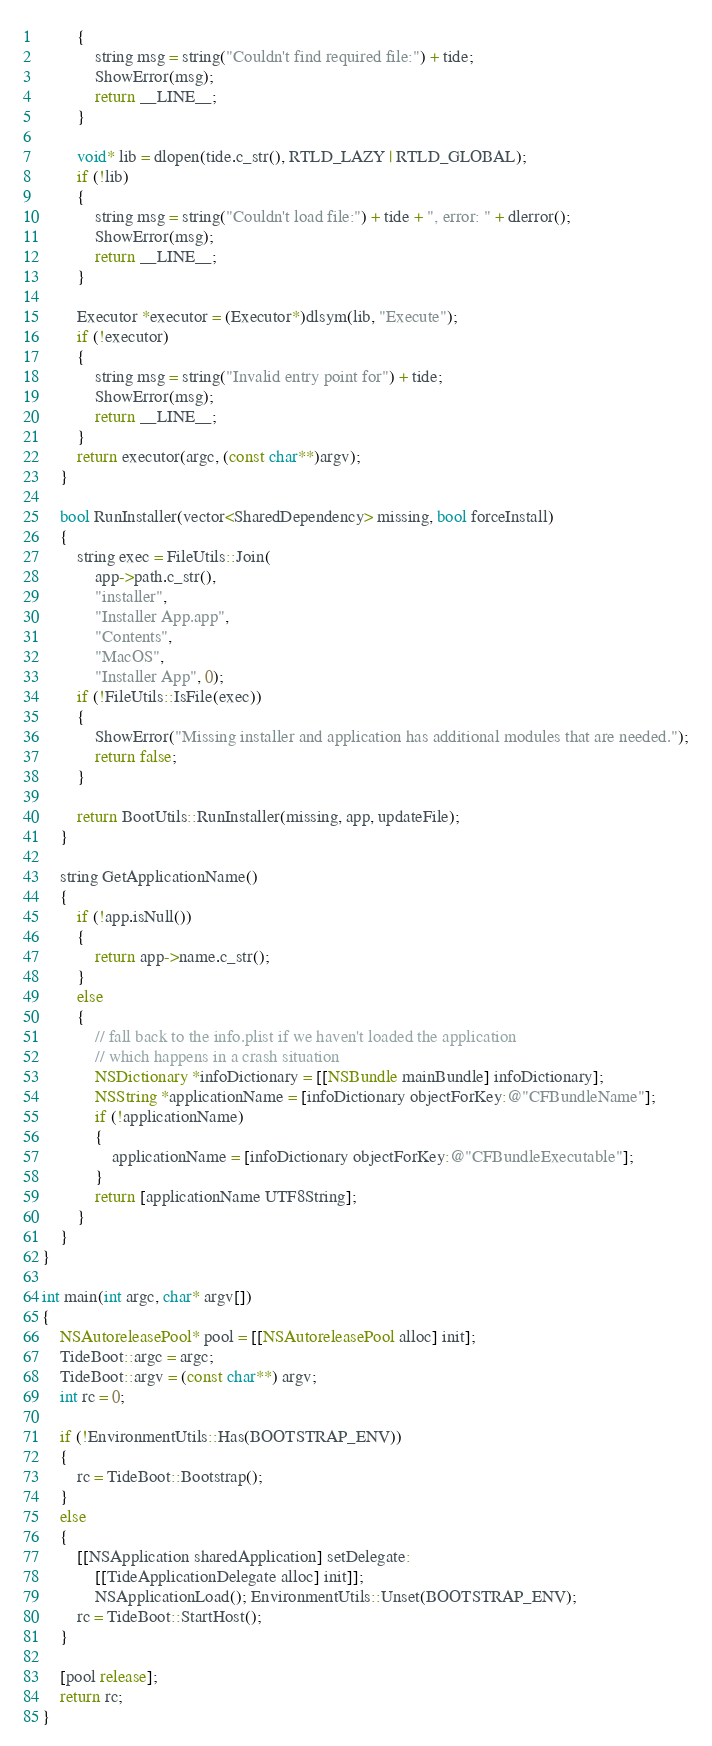Convert code to text. <code><loc_0><loc_0><loc_500><loc_500><_ObjectiveC_>        {
            string msg = string("Couldn't find required file:") + tide;
            ShowError(msg);
            return __LINE__;
        }
    
        void* lib = dlopen(tide.c_str(), RTLD_LAZY | RTLD_GLOBAL);
        if (!lib)
        {
            string msg = string("Couldn't load file:") + tide + ", error: " + dlerror();
            ShowError(msg);
            return __LINE__;
        }
    
        Executor *executor = (Executor*)dlsym(lib, "Execute");
        if (!executor)
        {
            string msg = string("Invalid entry point for") + tide;
            ShowError(msg);
            return __LINE__;
        }
        return executor(argc, (const char**)argv);
    }

    bool RunInstaller(vector<SharedDependency> missing, bool forceInstall)
    {
        string exec = FileUtils::Join(
            app->path.c_str(),
            "installer",
            "Installer App.app",
            "Contents", 
            "MacOS",
            "Installer App", 0);
        if (!FileUtils::IsFile(exec))
        {
            ShowError("Missing installer and application has additional modules that are needed.");
            return false;
        }

        return BootUtils::RunInstaller(missing, app, updateFile);
    }

    string GetApplicationName()
    {
        if (!app.isNull())
        {
            return app->name.c_str();
        }
        else
        {
            // fall back to the info.plist if we haven't loaded the application
            // which happens in a crash situation
            NSDictionary *infoDictionary = [[NSBundle mainBundle] infoDictionary];
            NSString *applicationName = [infoDictionary objectForKey:@"CFBundleName"];
            if (!applicationName) 
            {
                applicationName = [infoDictionary objectForKey:@"CFBundleExecutable"];
            }
            return [applicationName UTF8String];
        }
    }
}

int main(int argc, char* argv[])
{
    NSAutoreleasePool* pool = [[NSAutoreleasePool alloc] init];
    TideBoot::argc = argc;
    TideBoot::argv = (const char**) argv;
    int rc = 0;

    if (!EnvironmentUtils::Has(BOOTSTRAP_ENV))
    {
        rc = TideBoot::Bootstrap();
    }
    else
    {
        [[NSApplication sharedApplication] setDelegate:
            [[TideApplicationDelegate alloc] init]];
            NSApplicationLoad(); EnvironmentUtils::Unset(BOOTSTRAP_ENV);
        rc = TideBoot::StartHost();
    }

    [pool release];
    return rc;
}
</code> 